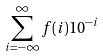<formula> <loc_0><loc_0><loc_500><loc_500>\sum _ { i = - \infty } ^ { \infty } f ( i ) 1 0 ^ { - i }</formula> 